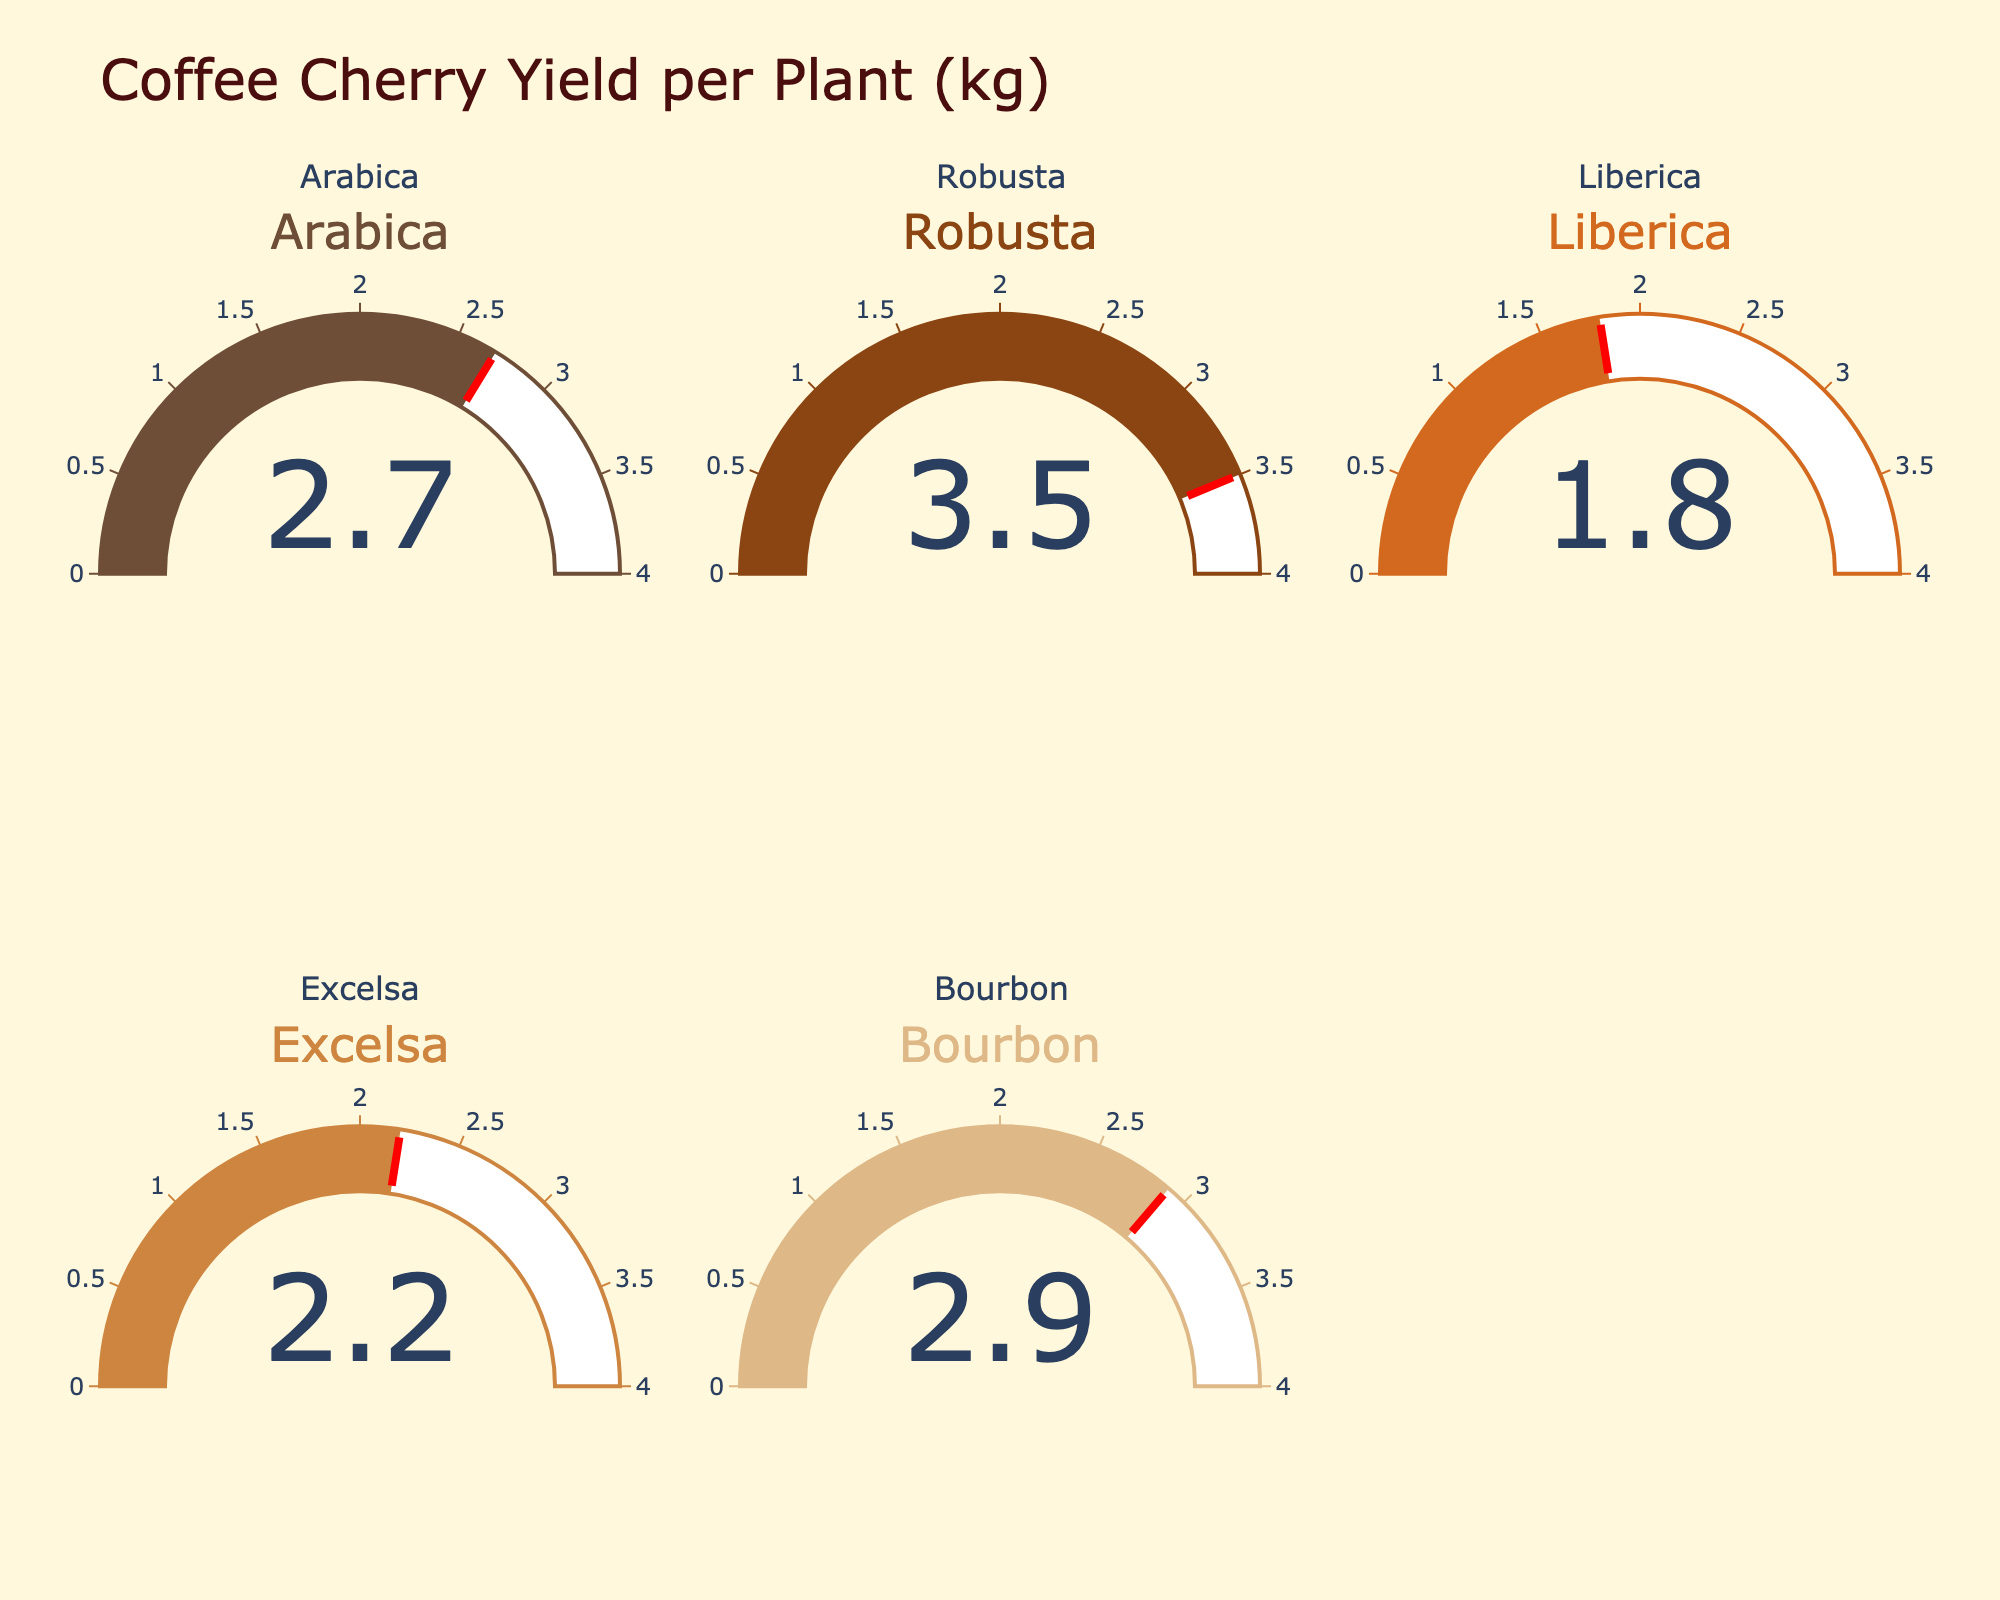what is the highest yield rate among the coffee varieties? The highest yield rate can be seen from the gauge chart of "Robusta," which shows a value of 3.5 kg per plant.
Answer: 3.5 What is the average yield rate across all coffee varieties? First, sum all the yields: 2.7 + 3.5 + 1.8 + 2.2 + 2.9 = 13.1 kg. Then divide by the number of varieties (5): 13.1 / 5 = 2.62 kg per plant.
Answer: 2.62 Which coffee variety has the lowest yield rate? The lowest yield rate can be seen from the gauge chart of "Liberica," with a value of 1.8 kg per plant.
Answer: Liberica How much higher is the yield rate of Robusta compared to that of Excelsa? The yield rate of Robusta is 3.5 kg, and that of Excelsa is 2.2 kg. The difference is 3.5 - 2.2 = 1.3 kg.
Answer: 1.3 Are the yield rates for Arabica and Bourbon above the average yield rate? The average yield rate is 2.62 kg. Both Arabica (2.7 kg) and Bourbon (2.9 kg) are above 2.62 kg.
Answer: Yes What's the difference between the highest and lowest yield rates? The highest yield rate is 3.5 kg (Robusta) and the lowest is 1.8 kg (Liberica). The difference is 3.5 - 1.8 = 1.7 kg.
Answer: 1.7 Which coffee varieties have a yield rate above 3 kg per plant? Only Robusta has a yield rate above 3 kg, which is 3.5 kg per plant.
Answer: Robusta How many coffee varieties have a yield rate of 2 kg per plant or higher? Arabica (2.7 kg), Robusta (3.5 kg), Bourbon (2.9 kg), and Excelsa (2.2 kg) all have yields of 2 kg or higher. This totals to 4 varieties.
Answer: 4 